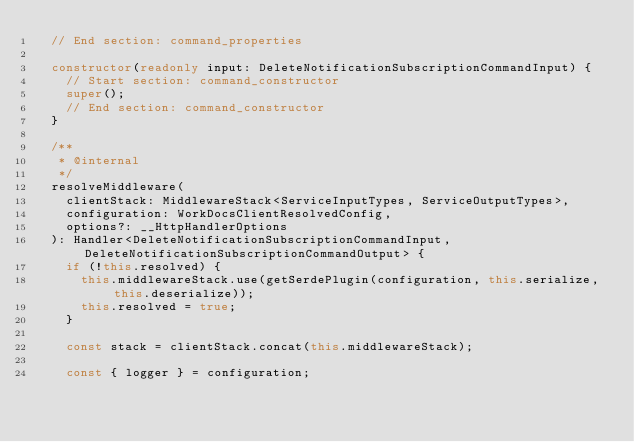Convert code to text. <code><loc_0><loc_0><loc_500><loc_500><_TypeScript_>  // End section: command_properties

  constructor(readonly input: DeleteNotificationSubscriptionCommandInput) {
    // Start section: command_constructor
    super();
    // End section: command_constructor
  }

  /**
   * @internal
   */
  resolveMiddleware(
    clientStack: MiddlewareStack<ServiceInputTypes, ServiceOutputTypes>,
    configuration: WorkDocsClientResolvedConfig,
    options?: __HttpHandlerOptions
  ): Handler<DeleteNotificationSubscriptionCommandInput, DeleteNotificationSubscriptionCommandOutput> {
    if (!this.resolved) {
      this.middlewareStack.use(getSerdePlugin(configuration, this.serialize, this.deserialize));
      this.resolved = true;
    }

    const stack = clientStack.concat(this.middlewareStack);

    const { logger } = configuration;</code> 